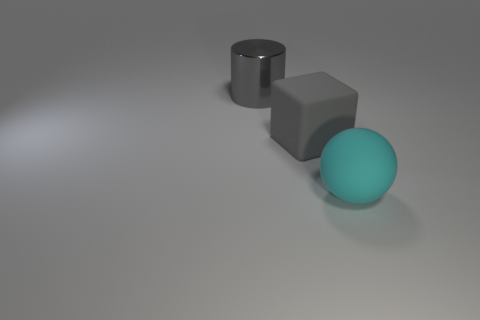How would you describe the texture of the surface on which the objects are placed? The surface texture in this image has a smooth and matte finish, with a subtle speckled pattern suggesting it could be a material like concrete or stone, creating a neutral background that doesn't distract from the objects. Is there any indication of the size of these objects relative to each other? The objects appear to have been placed intentionally to show a range of sizes and shapes. However, without a common reference object, it is difficult to ascertain their exact size relative to real-world objects. They are depicted in a scale where the cylinder and cube are similar in size with the sphere being slightly larger than both. 